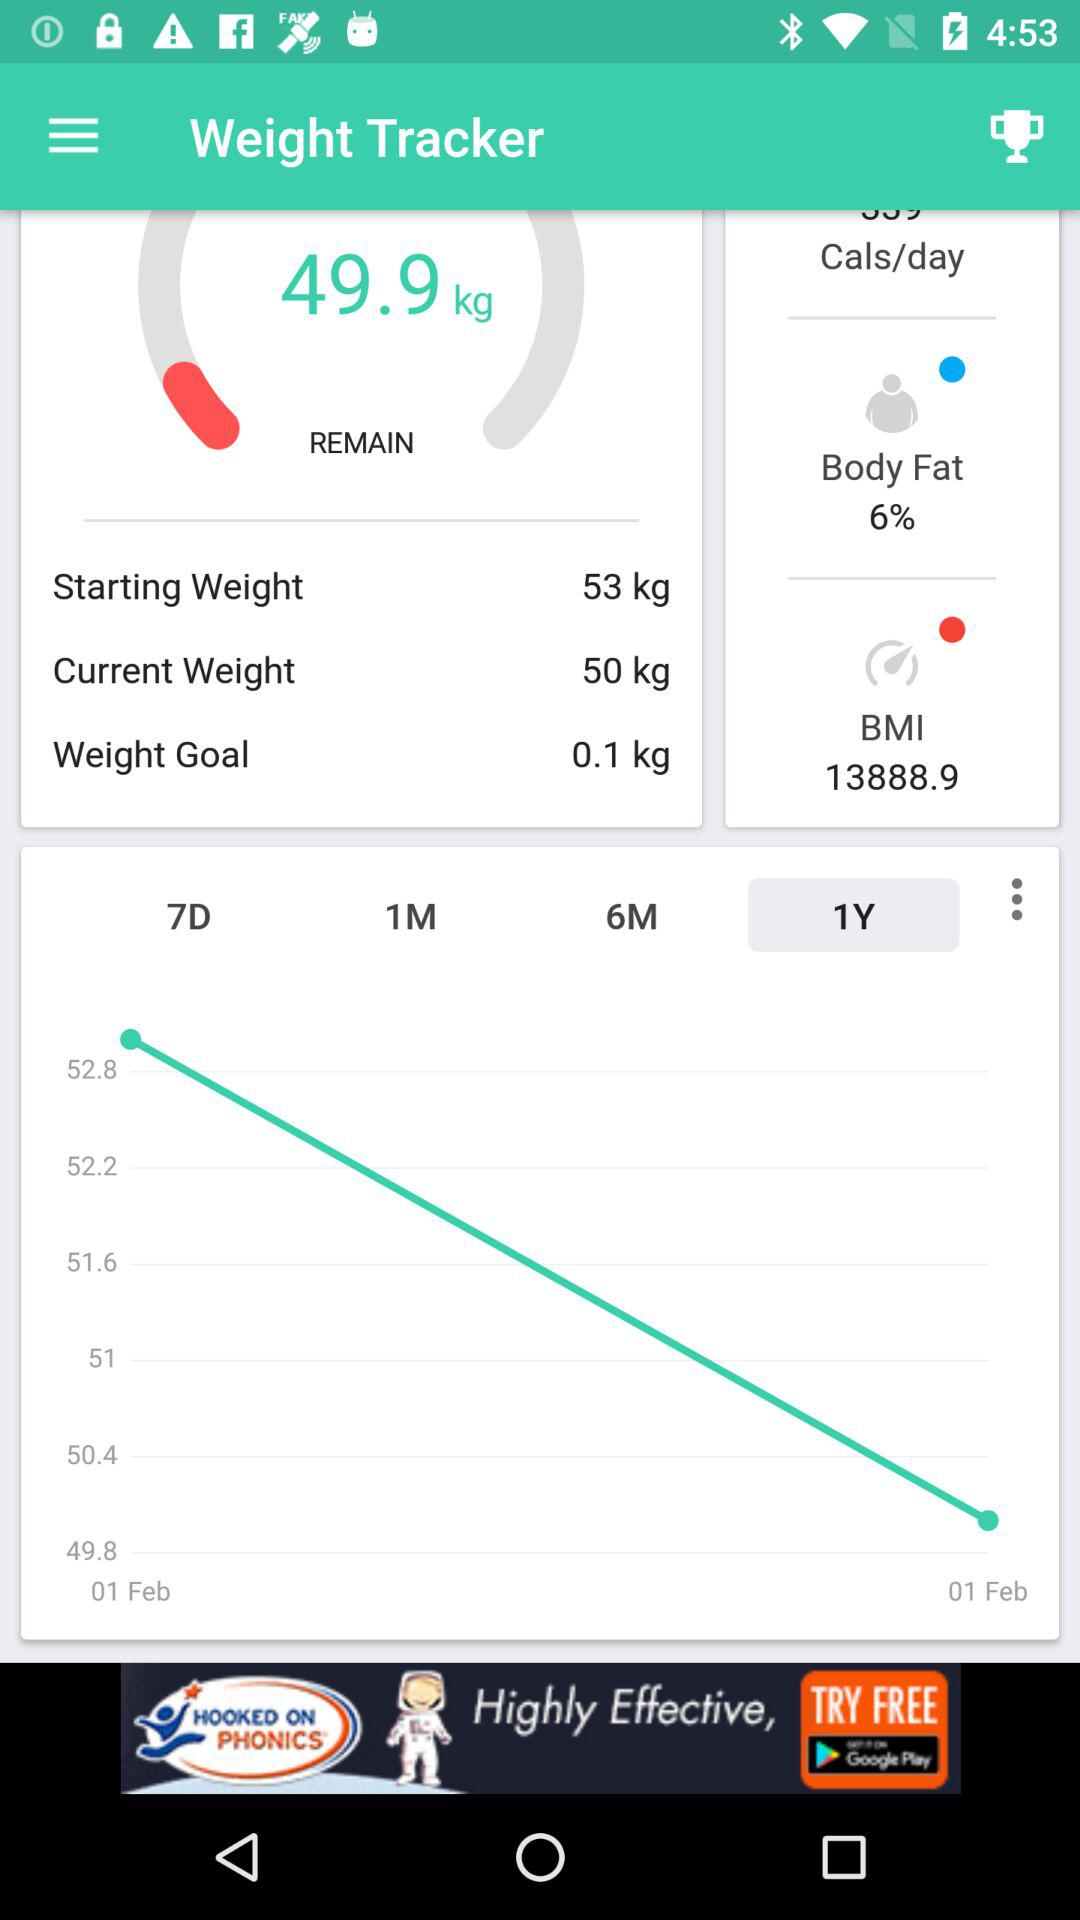What is the BMI of the body? The BMI of the body is 13888.9. 